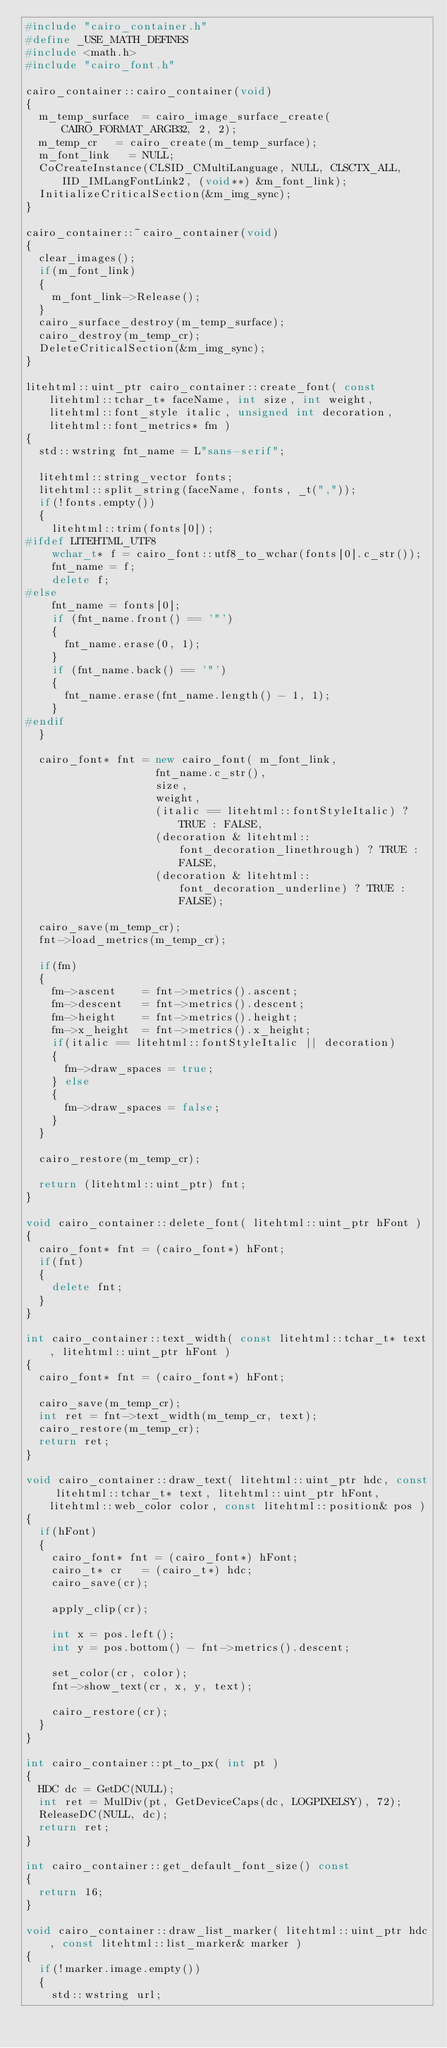Convert code to text. <code><loc_0><loc_0><loc_500><loc_500><_C++_>#include "cairo_container.h"
#define _USE_MATH_DEFINES
#include <math.h>
#include "cairo_font.h"

cairo_container::cairo_container(void)
{
	m_temp_surface	= cairo_image_surface_create(CAIRO_FORMAT_ARGB32, 2, 2);
	m_temp_cr		= cairo_create(m_temp_surface);
	m_font_link		= NULL;
	CoCreateInstance(CLSID_CMultiLanguage, NULL, CLSCTX_ALL, IID_IMLangFontLink2, (void**) &m_font_link);
	InitializeCriticalSection(&m_img_sync);
}

cairo_container::~cairo_container(void)
{
	clear_images();
	if(m_font_link)
	{
		m_font_link->Release();
	}
	cairo_surface_destroy(m_temp_surface);
	cairo_destroy(m_temp_cr);
	DeleteCriticalSection(&m_img_sync);
}

litehtml::uint_ptr cairo_container::create_font( const litehtml::tchar_t* faceName, int size, int weight, litehtml::font_style italic, unsigned int decoration, litehtml::font_metrics* fm )
{
	std::wstring fnt_name = L"sans-serif";

	litehtml::string_vector fonts;
	litehtml::split_string(faceName, fonts, _t(","));
	if(!fonts.empty())
	{
		litehtml::trim(fonts[0]);
#ifdef LITEHTML_UTF8
		wchar_t* f = cairo_font::utf8_to_wchar(fonts[0].c_str());
		fnt_name = f;
		delete f;
#else
		fnt_name = fonts[0];
		if (fnt_name.front() == '"')
		{
			fnt_name.erase(0, 1);
		}
		if (fnt_name.back() == '"')
		{
			fnt_name.erase(fnt_name.length() - 1, 1);
		}
#endif
	}

	cairo_font* fnt = new cairo_font(	m_font_link,
										fnt_name.c_str(), 
										size, 
										weight, 
										(italic == litehtml::fontStyleItalic) ? TRUE : FALSE,
										(decoration & litehtml::font_decoration_linethrough) ? TRUE : FALSE,
										(decoration & litehtml::font_decoration_underline) ? TRUE : FALSE);

	cairo_save(m_temp_cr);
	fnt->load_metrics(m_temp_cr);

	if(fm)
	{
		fm->ascent		= fnt->metrics().ascent;
		fm->descent		= fnt->metrics().descent;
		fm->height		= fnt->metrics().height;
		fm->x_height	= fnt->metrics().x_height;
		if(italic == litehtml::fontStyleItalic || decoration)
		{
			fm->draw_spaces = true;
		} else
		{
			fm->draw_spaces = false;
		}
	}

	cairo_restore(m_temp_cr);

	return (litehtml::uint_ptr) fnt;
}

void cairo_container::delete_font( litehtml::uint_ptr hFont )
{
	cairo_font* fnt = (cairo_font*) hFont;
	if(fnt)
	{
		delete fnt;
	}
}

int cairo_container::text_width( const litehtml::tchar_t* text, litehtml::uint_ptr hFont )
{
	cairo_font* fnt = (cairo_font*) hFont;
	
	cairo_save(m_temp_cr);
	int ret = fnt->text_width(m_temp_cr, text);
	cairo_restore(m_temp_cr);
	return ret;
}

void cairo_container::draw_text( litehtml::uint_ptr hdc, const litehtml::tchar_t* text, litehtml::uint_ptr hFont, litehtml::web_color color, const litehtml::position& pos )
{
	if(hFont)
	{
		cairo_font* fnt = (cairo_font*) hFont;
		cairo_t* cr		= (cairo_t*) hdc;
		cairo_save(cr);

		apply_clip(cr);

		int x = pos.left();
		int y = pos.bottom() - fnt->metrics().descent;

		set_color(cr, color);
		fnt->show_text(cr, x, y, text);

		cairo_restore(cr);
	}
}

int cairo_container::pt_to_px( int pt )
{
	HDC dc = GetDC(NULL);
	int ret = MulDiv(pt, GetDeviceCaps(dc, LOGPIXELSY), 72);
	ReleaseDC(NULL, dc);
	return ret;
}

int cairo_container::get_default_font_size() const
{
	return 16;
}

void cairo_container::draw_list_marker( litehtml::uint_ptr hdc, const litehtml::list_marker& marker )
{
	if(!marker.image.empty())
	{
		std::wstring url;</code> 